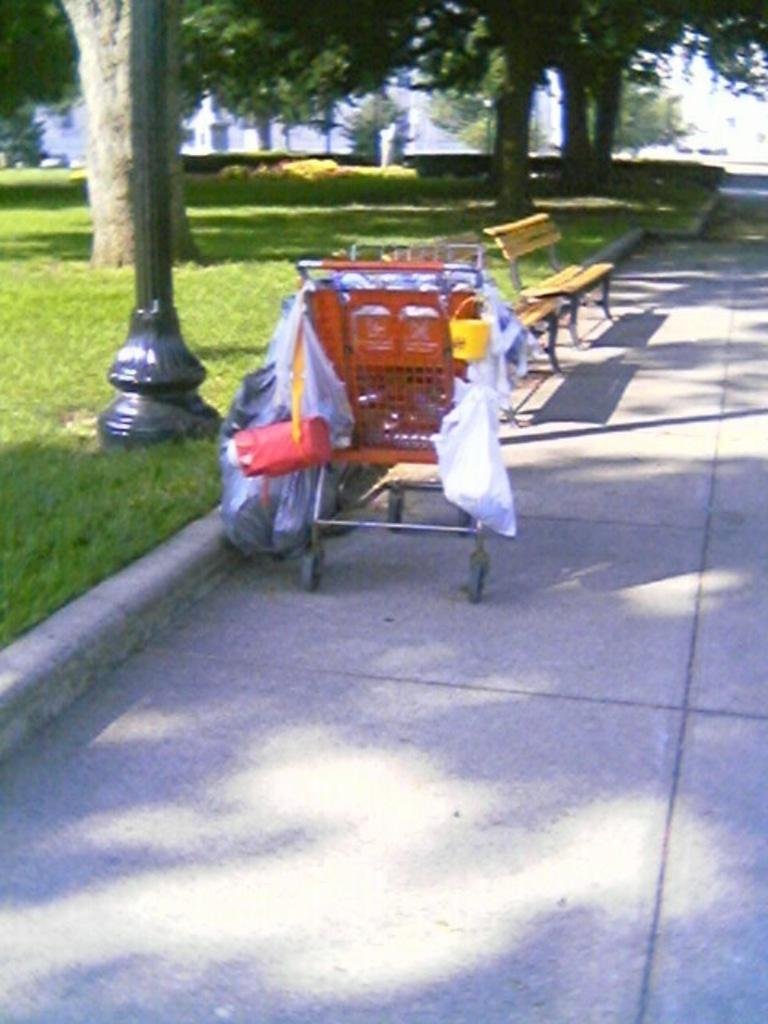What type of objects can be seen in the image? There are trolleys and benches in the image. What is the surface that the trolleys and benches are placed on? The bottom of the image contains a floor. What can be seen in the background of the image? There are trees in the background of the image. What type of vegetation is on the left side of the image? There is grass on the left side of the image. What type of frame is around the image? The image does not have a frame; it is a photograph or digital image without a physical frame. What does the grandfather do in the image? There is no grandfather present in the image. 